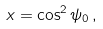Convert formula to latex. <formula><loc_0><loc_0><loc_500><loc_500>x = \cos ^ { 2 } \psi _ { 0 } \, ,</formula> 